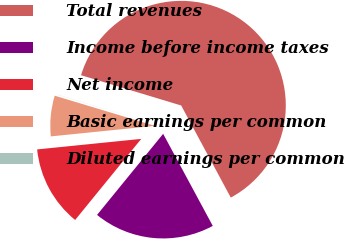Convert chart. <chart><loc_0><loc_0><loc_500><loc_500><pie_chart><fcel>Total revenues<fcel>Income before income taxes<fcel>Net income<fcel>Basic earnings per common<fcel>Diluted earnings per common<nl><fcel>62.46%<fcel>18.75%<fcel>12.51%<fcel>6.26%<fcel>0.02%<nl></chart> 